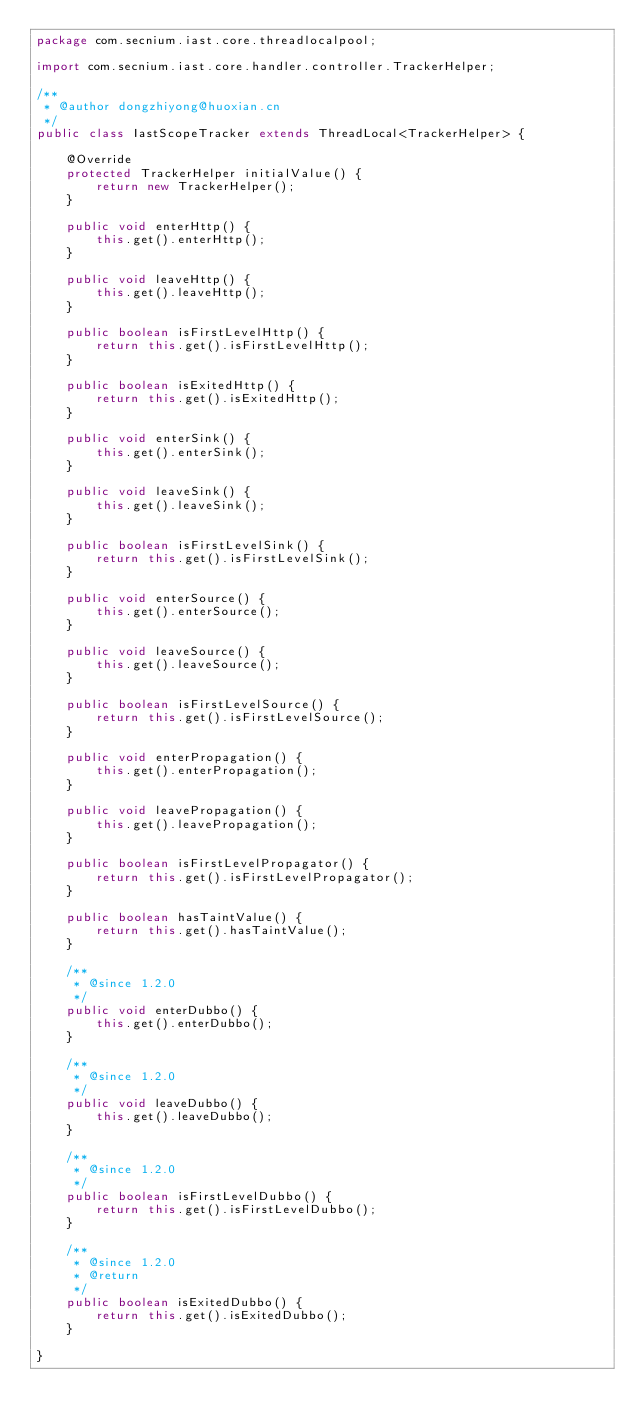Convert code to text. <code><loc_0><loc_0><loc_500><loc_500><_Java_>package com.secnium.iast.core.threadlocalpool;

import com.secnium.iast.core.handler.controller.TrackerHelper;

/**
 * @author dongzhiyong@huoxian.cn
 */
public class IastScopeTracker extends ThreadLocal<TrackerHelper> {

    @Override
    protected TrackerHelper initialValue() {
        return new TrackerHelper();
    }

    public void enterHttp() {
        this.get().enterHttp();
    }

    public void leaveHttp() {
        this.get().leaveHttp();
    }

    public boolean isFirstLevelHttp() {
        return this.get().isFirstLevelHttp();
    }

    public boolean isExitedHttp() {
        return this.get().isExitedHttp();
    }

    public void enterSink() {
        this.get().enterSink();
    }

    public void leaveSink() {
        this.get().leaveSink();
    }

    public boolean isFirstLevelSink() {
        return this.get().isFirstLevelSink();
    }

    public void enterSource() {
        this.get().enterSource();
    }

    public void leaveSource() {
        this.get().leaveSource();
    }

    public boolean isFirstLevelSource() {
        return this.get().isFirstLevelSource();
    }

    public void enterPropagation() {
        this.get().enterPropagation();
    }

    public void leavePropagation() {
        this.get().leavePropagation();
    }

    public boolean isFirstLevelPropagator() {
        return this.get().isFirstLevelPropagator();
    }

    public boolean hasTaintValue() {
        return this.get().hasTaintValue();
    }

    /**
     * @since 1.2.0
     */
    public void enterDubbo() {
        this.get().enterDubbo();
    }

    /**
     * @since 1.2.0
     */
    public void leaveDubbo() {
        this.get().leaveDubbo();
    }

    /**
     * @since 1.2.0
     */
    public boolean isFirstLevelDubbo() {
        return this.get().isFirstLevelDubbo();
    }

    /**
     * @since 1.2.0
     * @return
     */
    public boolean isExitedDubbo() {
        return this.get().isExitedDubbo();
    }

}
</code> 